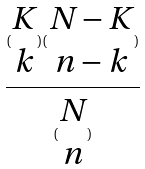<formula> <loc_0><loc_0><loc_500><loc_500>\frac { ( \begin{matrix} K \\ k \end{matrix} ) ( \begin{matrix} N - K \\ n - k \end{matrix} ) } { ( \begin{matrix} N \\ n \end{matrix} ) }</formula> 